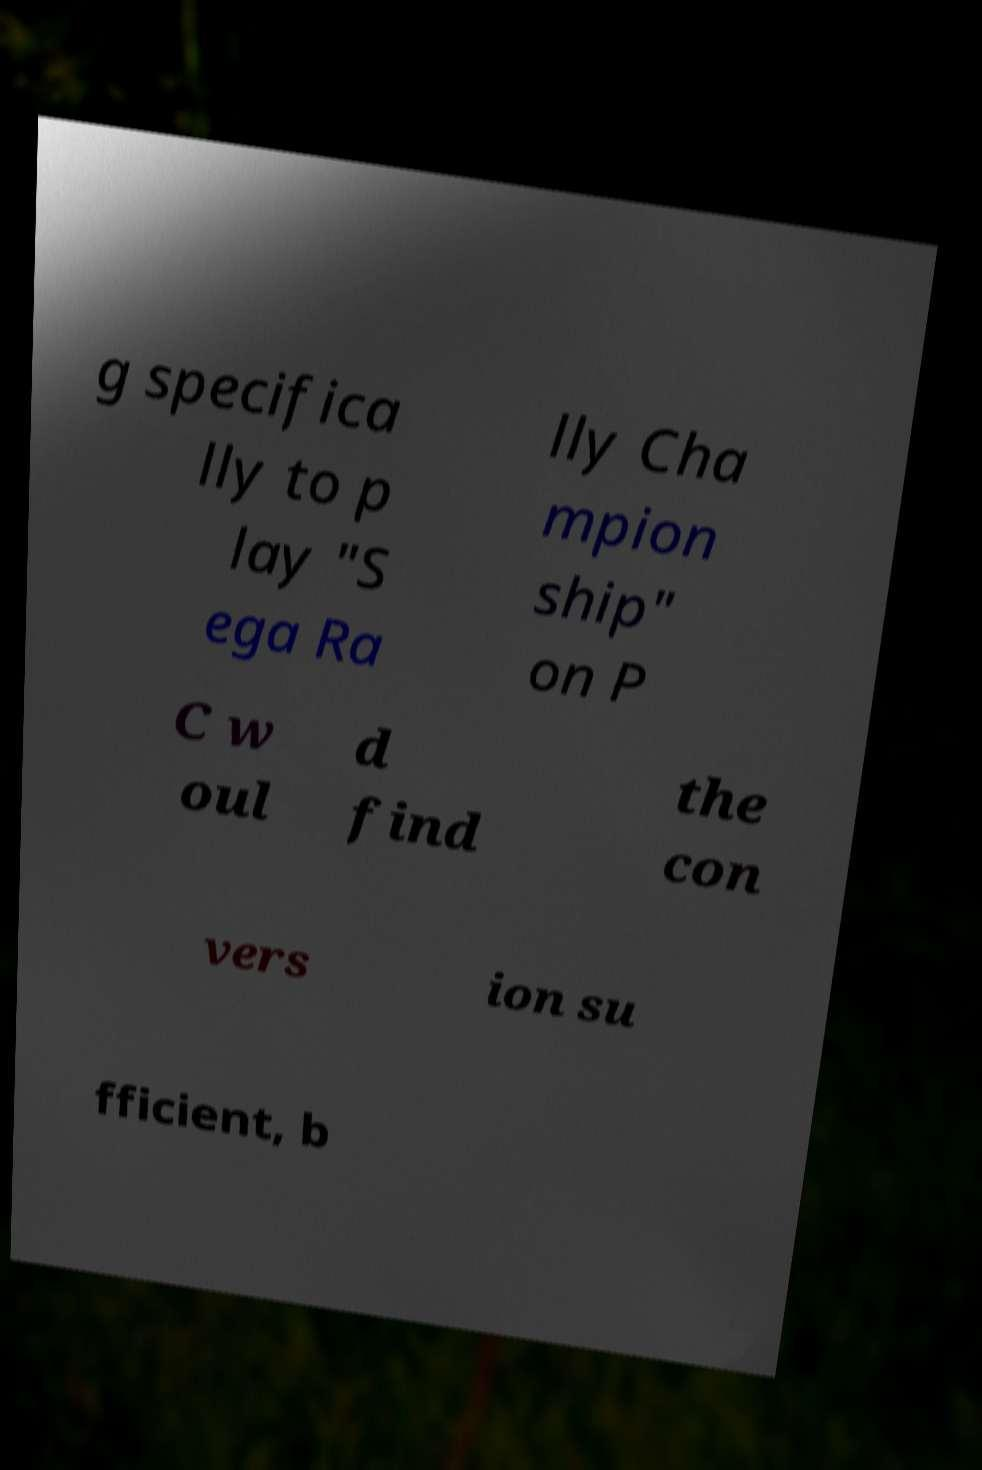Could you extract and type out the text from this image? g specifica lly to p lay "S ega Ra lly Cha mpion ship" on P C w oul d find the con vers ion su fficient, b 